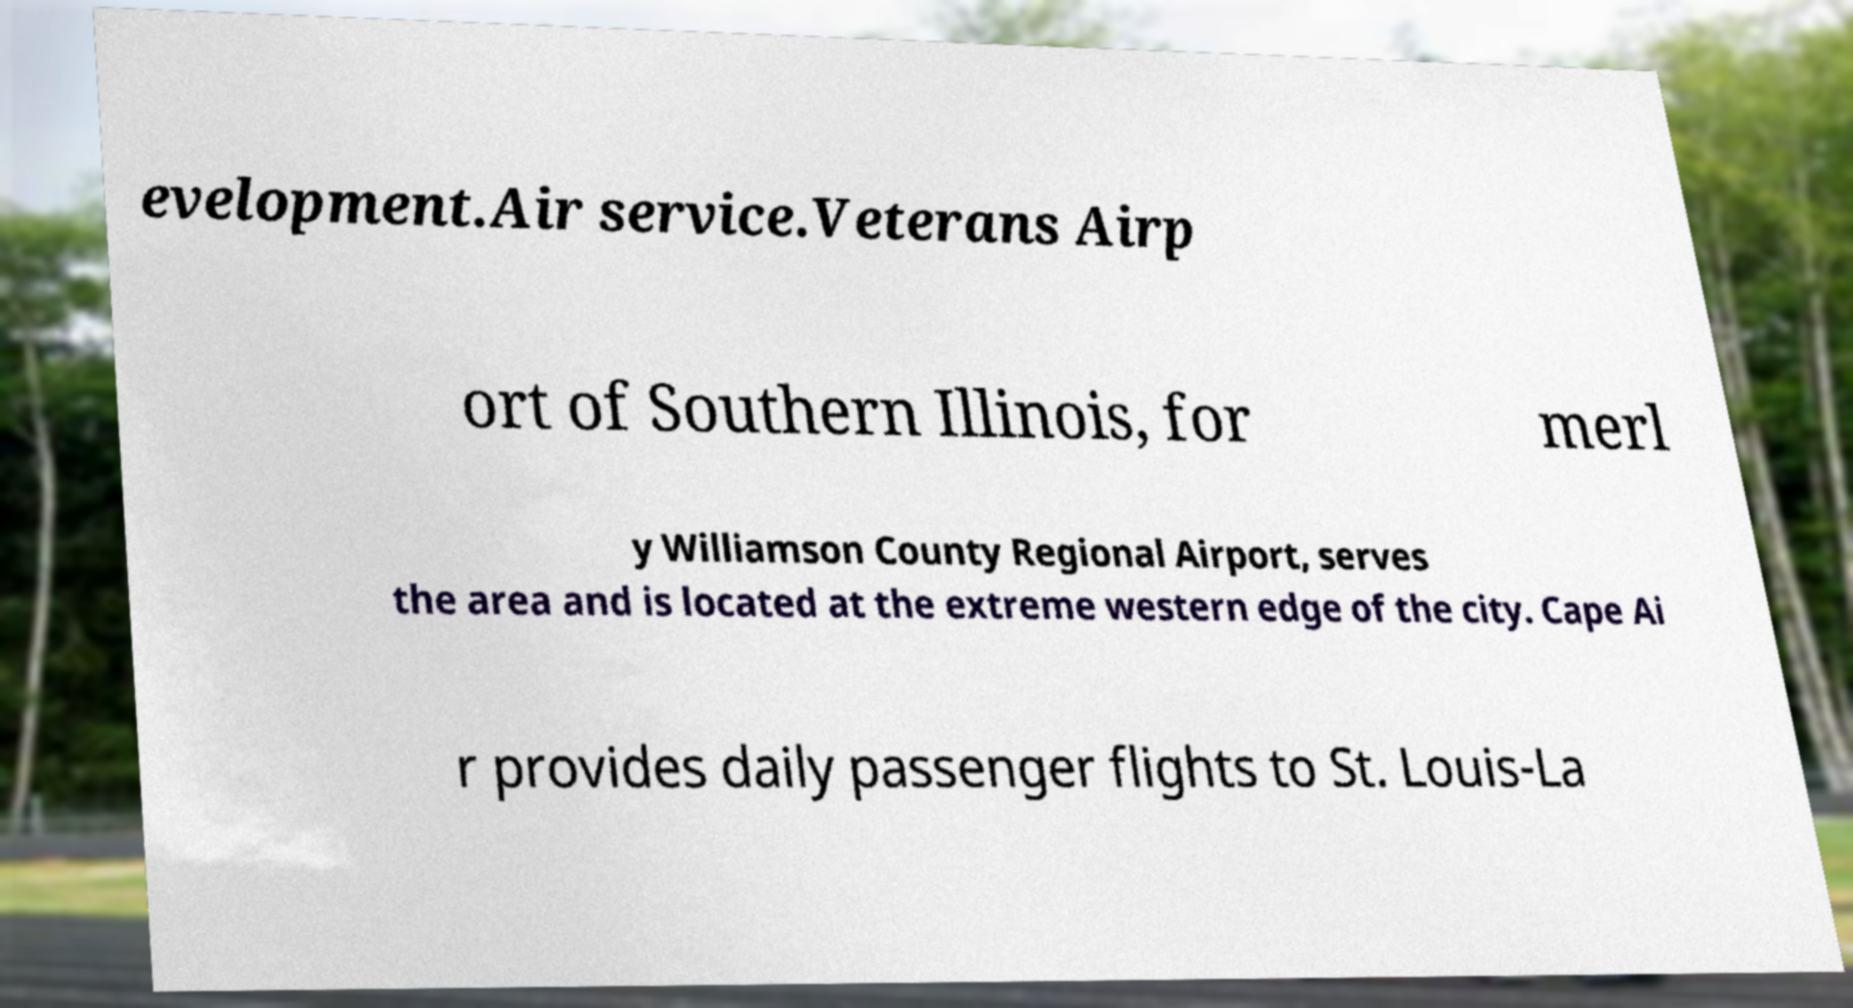Please read and relay the text visible in this image. What does it say? evelopment.Air service.Veterans Airp ort of Southern Illinois, for merl y Williamson County Regional Airport, serves the area and is located at the extreme western edge of the city. Cape Ai r provides daily passenger flights to St. Louis-La 